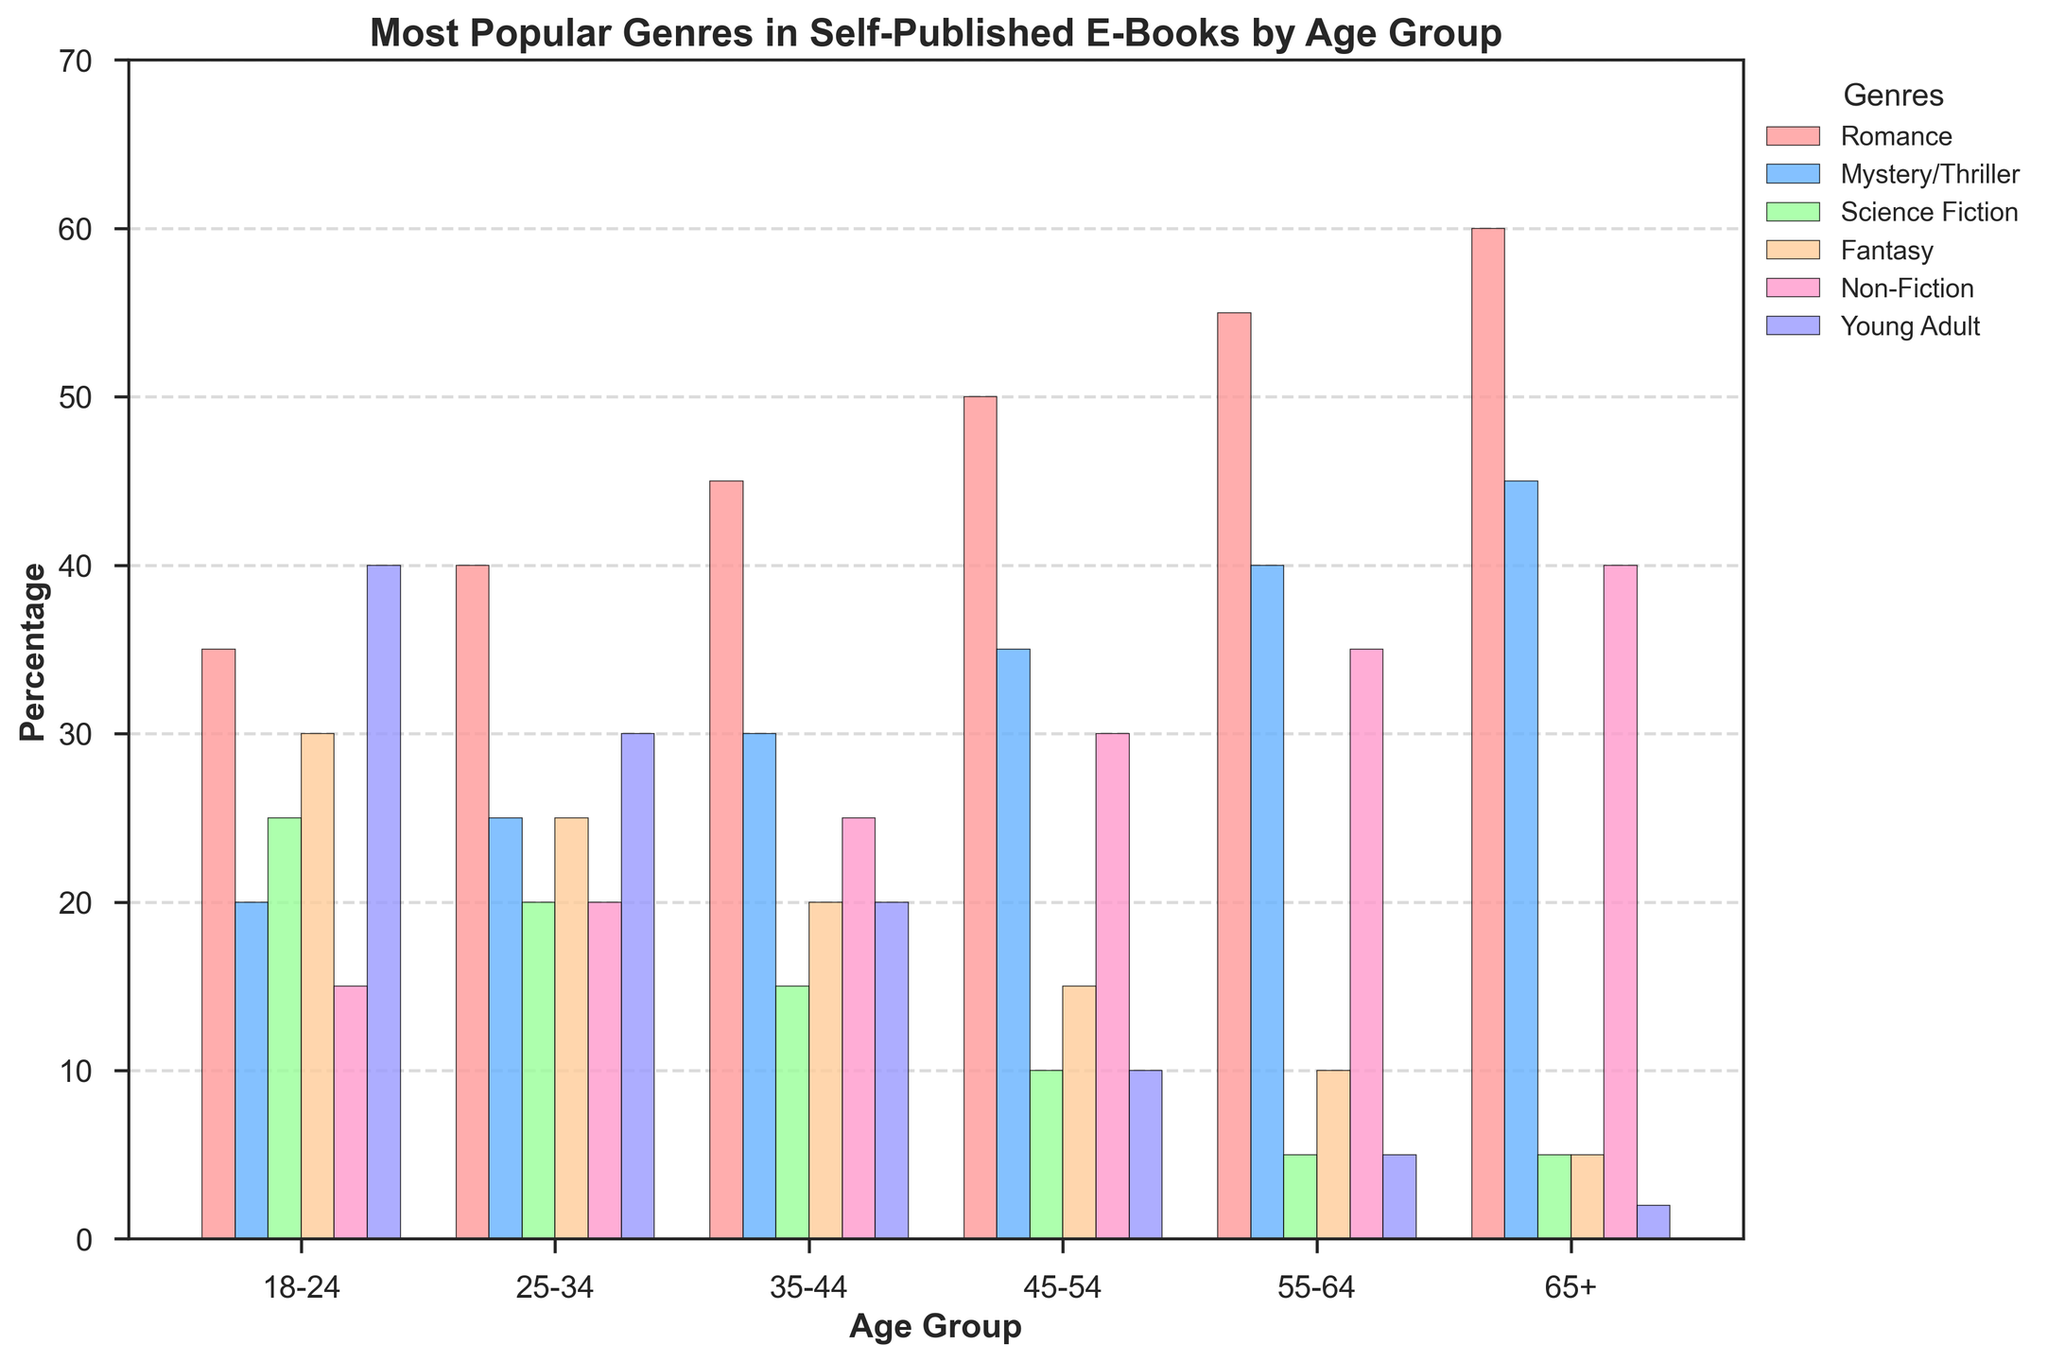What's the most popular genre for the age group 65+? The tallest bar within the 65+ age group cluster corresponds to the Romance genre.
Answer: Romance Which age group prefers Young Adult books the most? The bar representing Young Adult books is the tallest for the 18-24 age group compared to all other age groups.
Answer: 18-24 For the age group 35-44, how does the popularity of Fantasy compare to Science Fiction? The bar for Fantasy in the 35-44 age group is higher than the bar for Science Fiction.
Answer: Fantasy is more popular What's the sum of percentages for Mystery/Thriller books across all age groups? Sum the height of the Mystery/Thriller bars for all age groups: 20+25+30+35+40+45 = 195.
Answer: 195 Which genre shows a consistent increase in popularity with age? The Romance genre bars show a consistent increase in height from the 18-24 age group to the 65+ age group.
Answer: Romance How does the popularity of Non-Fiction books for the 55-64 age group compare to Non-Fiction books for the 25-34 age group? The bar for Non-Fiction is higher for the 55-64 age group compared to the 25-34 age group.
Answer: 55-64 is more Which age group has the smallest preference for Young Adult books? The shortest bar for Young Adult books appears in the 65+ age group cluster.
Answer: 65+ What's the average percentage of Romance books across all age groups? Sum the percentages for Romance genre: 35+40+45+50+55+60 = 285. Then divide by the number of age groups: 285/6 = 47.5.
Answer: 47.5 Which age group has the highest overall sum across all genres? Sum the heights of all bars in each age group and compare. 65+:35+45+5+5+40+2 = 192, 55-64:55+40+5+10+35+5=150, and so on. The highest total is for 65+.
Answer: 65+ Between the genres of Fantasy and Young Adult, which one sees a greater drop in popularity from 18-24 to 65+? Compare the height difference for the bars in 18-24 and 65+ clusters. Fantasy: 30-5=25, Young Adult: 40-2=38.
Answer: Young Adult 